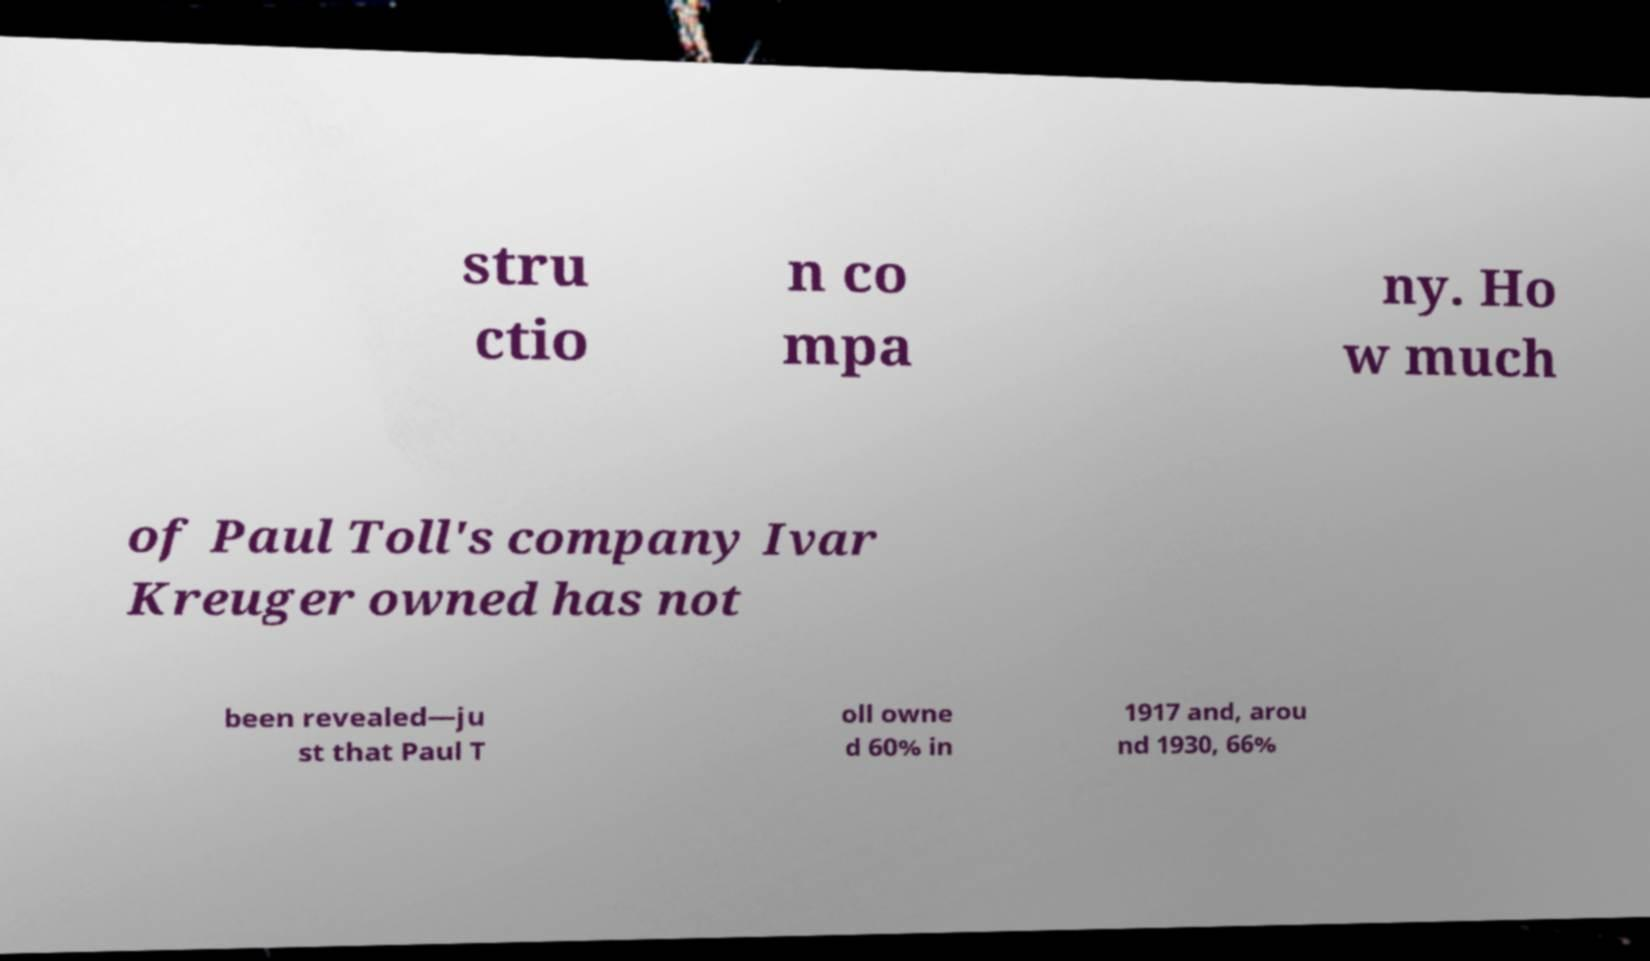For documentation purposes, I need the text within this image transcribed. Could you provide that? stru ctio n co mpa ny. Ho w much of Paul Toll's company Ivar Kreuger owned has not been revealed—ju st that Paul T oll owne d 60% in 1917 and, arou nd 1930, 66% 